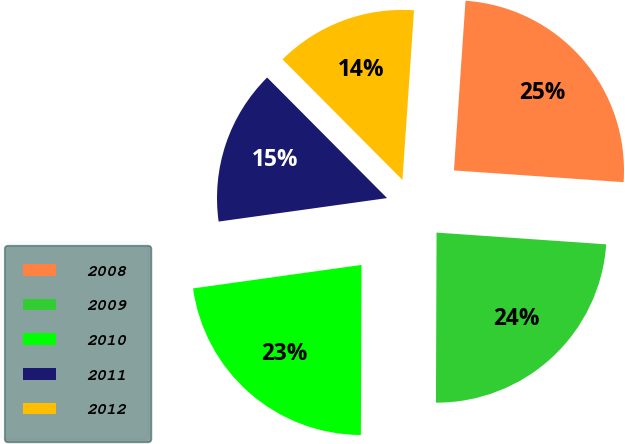<chart> <loc_0><loc_0><loc_500><loc_500><pie_chart><fcel>2008<fcel>2009<fcel>2010<fcel>2011<fcel>2012<nl><fcel>25.02%<fcel>23.96%<fcel>22.74%<fcel>14.75%<fcel>13.54%<nl></chart> 